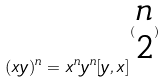Convert formula to latex. <formula><loc_0><loc_0><loc_500><loc_500>( x y ) ^ { n } = x ^ { n } y ^ { n } [ y , x ] ^ { ( \begin{matrix} n \\ 2 \end{matrix} ) }</formula> 